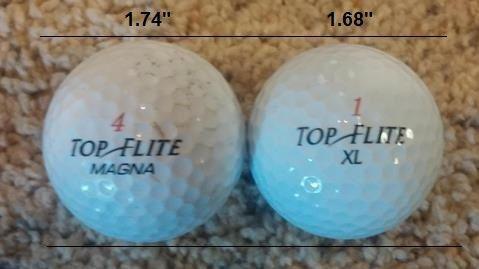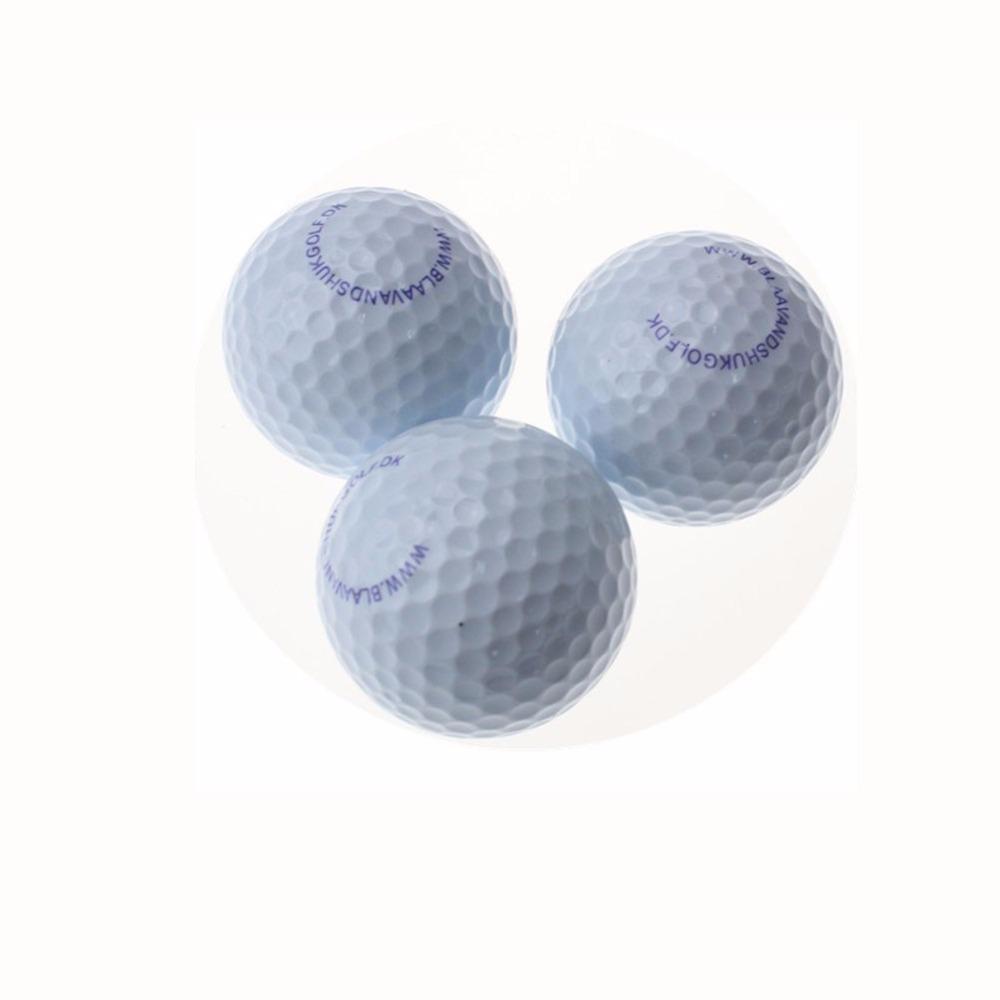The first image is the image on the left, the second image is the image on the right. Evaluate the accuracy of this statement regarding the images: "The right image contains exactly three golf balls in a triangular formation.". Is it true? Answer yes or no. Yes. The first image is the image on the left, the second image is the image on the right. For the images displayed, is the sentence "One image shows a pyramid shape formed by three golf balls, and the other image contains no more than one golf ball." factually correct? Answer yes or no. No. 